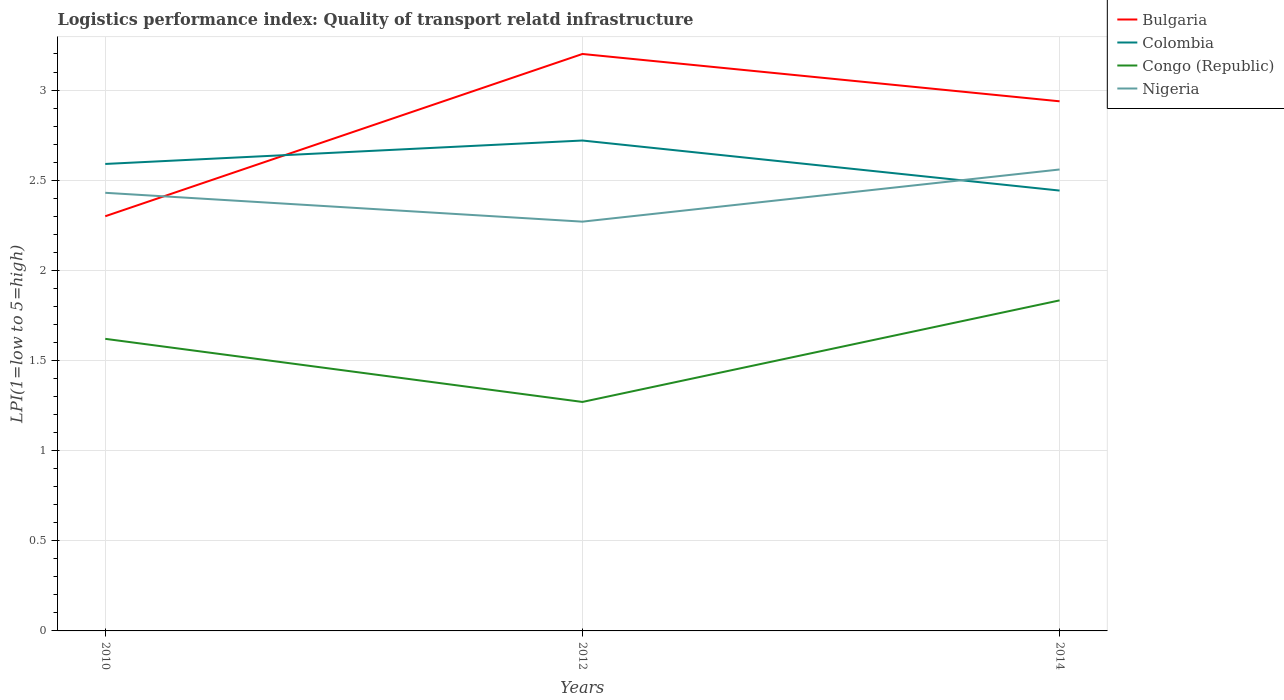How many different coloured lines are there?
Make the answer very short. 4. Is the number of lines equal to the number of legend labels?
Keep it short and to the point. Yes. Across all years, what is the maximum logistics performance index in Nigeria?
Your response must be concise. 2.27. In which year was the logistics performance index in Congo (Republic) maximum?
Your answer should be compact. 2012. What is the total logistics performance index in Bulgaria in the graph?
Offer a terse response. -0.9. What is the difference between the highest and the second highest logistics performance index in Nigeria?
Keep it short and to the point. 0.29. Is the logistics performance index in Bulgaria strictly greater than the logistics performance index in Nigeria over the years?
Make the answer very short. No. How many years are there in the graph?
Ensure brevity in your answer.  3. How many legend labels are there?
Your response must be concise. 4. How are the legend labels stacked?
Provide a short and direct response. Vertical. What is the title of the graph?
Offer a terse response. Logistics performance index: Quality of transport relatd infrastructure. What is the label or title of the Y-axis?
Make the answer very short. LPI(1=low to 5=high). What is the LPI(1=low to 5=high) in Colombia in 2010?
Provide a short and direct response. 2.59. What is the LPI(1=low to 5=high) in Congo (Republic) in 2010?
Keep it short and to the point. 1.62. What is the LPI(1=low to 5=high) of Nigeria in 2010?
Ensure brevity in your answer.  2.43. What is the LPI(1=low to 5=high) in Bulgaria in 2012?
Make the answer very short. 3.2. What is the LPI(1=low to 5=high) in Colombia in 2012?
Give a very brief answer. 2.72. What is the LPI(1=low to 5=high) in Congo (Republic) in 2012?
Your answer should be compact. 1.27. What is the LPI(1=low to 5=high) in Nigeria in 2012?
Your answer should be compact. 2.27. What is the LPI(1=low to 5=high) of Bulgaria in 2014?
Provide a succinct answer. 2.94. What is the LPI(1=low to 5=high) of Colombia in 2014?
Ensure brevity in your answer.  2.44. What is the LPI(1=low to 5=high) in Congo (Republic) in 2014?
Provide a succinct answer. 1.83. What is the LPI(1=low to 5=high) of Nigeria in 2014?
Offer a terse response. 2.56. Across all years, what is the maximum LPI(1=low to 5=high) in Bulgaria?
Your answer should be very brief. 3.2. Across all years, what is the maximum LPI(1=low to 5=high) in Colombia?
Your answer should be very brief. 2.72. Across all years, what is the maximum LPI(1=low to 5=high) in Congo (Republic)?
Make the answer very short. 1.83. Across all years, what is the maximum LPI(1=low to 5=high) in Nigeria?
Offer a very short reply. 2.56. Across all years, what is the minimum LPI(1=low to 5=high) in Bulgaria?
Ensure brevity in your answer.  2.3. Across all years, what is the minimum LPI(1=low to 5=high) in Colombia?
Offer a very short reply. 2.44. Across all years, what is the minimum LPI(1=low to 5=high) in Congo (Republic)?
Your answer should be very brief. 1.27. Across all years, what is the minimum LPI(1=low to 5=high) in Nigeria?
Provide a short and direct response. 2.27. What is the total LPI(1=low to 5=high) of Bulgaria in the graph?
Offer a very short reply. 8.44. What is the total LPI(1=low to 5=high) in Colombia in the graph?
Keep it short and to the point. 7.75. What is the total LPI(1=low to 5=high) of Congo (Republic) in the graph?
Your answer should be very brief. 4.72. What is the total LPI(1=low to 5=high) in Nigeria in the graph?
Give a very brief answer. 7.26. What is the difference between the LPI(1=low to 5=high) in Colombia in 2010 and that in 2012?
Provide a succinct answer. -0.13. What is the difference between the LPI(1=low to 5=high) in Congo (Republic) in 2010 and that in 2012?
Offer a very short reply. 0.35. What is the difference between the LPI(1=low to 5=high) in Nigeria in 2010 and that in 2012?
Give a very brief answer. 0.16. What is the difference between the LPI(1=low to 5=high) in Bulgaria in 2010 and that in 2014?
Your answer should be very brief. -0.64. What is the difference between the LPI(1=low to 5=high) of Colombia in 2010 and that in 2014?
Offer a very short reply. 0.15. What is the difference between the LPI(1=low to 5=high) in Congo (Republic) in 2010 and that in 2014?
Your answer should be compact. -0.21. What is the difference between the LPI(1=low to 5=high) of Nigeria in 2010 and that in 2014?
Keep it short and to the point. -0.13. What is the difference between the LPI(1=low to 5=high) of Bulgaria in 2012 and that in 2014?
Ensure brevity in your answer.  0.26. What is the difference between the LPI(1=low to 5=high) in Colombia in 2012 and that in 2014?
Offer a terse response. 0.28. What is the difference between the LPI(1=low to 5=high) in Congo (Republic) in 2012 and that in 2014?
Make the answer very short. -0.56. What is the difference between the LPI(1=low to 5=high) of Nigeria in 2012 and that in 2014?
Your answer should be very brief. -0.29. What is the difference between the LPI(1=low to 5=high) in Bulgaria in 2010 and the LPI(1=low to 5=high) in Colombia in 2012?
Your answer should be very brief. -0.42. What is the difference between the LPI(1=low to 5=high) of Bulgaria in 2010 and the LPI(1=low to 5=high) of Congo (Republic) in 2012?
Ensure brevity in your answer.  1.03. What is the difference between the LPI(1=low to 5=high) of Bulgaria in 2010 and the LPI(1=low to 5=high) of Nigeria in 2012?
Offer a terse response. 0.03. What is the difference between the LPI(1=low to 5=high) of Colombia in 2010 and the LPI(1=low to 5=high) of Congo (Republic) in 2012?
Offer a very short reply. 1.32. What is the difference between the LPI(1=low to 5=high) of Colombia in 2010 and the LPI(1=low to 5=high) of Nigeria in 2012?
Keep it short and to the point. 0.32. What is the difference between the LPI(1=low to 5=high) of Congo (Republic) in 2010 and the LPI(1=low to 5=high) of Nigeria in 2012?
Your answer should be compact. -0.65. What is the difference between the LPI(1=low to 5=high) in Bulgaria in 2010 and the LPI(1=low to 5=high) in Colombia in 2014?
Ensure brevity in your answer.  -0.14. What is the difference between the LPI(1=low to 5=high) of Bulgaria in 2010 and the LPI(1=low to 5=high) of Congo (Republic) in 2014?
Provide a short and direct response. 0.47. What is the difference between the LPI(1=low to 5=high) of Bulgaria in 2010 and the LPI(1=low to 5=high) of Nigeria in 2014?
Give a very brief answer. -0.26. What is the difference between the LPI(1=low to 5=high) of Colombia in 2010 and the LPI(1=low to 5=high) of Congo (Republic) in 2014?
Your answer should be very brief. 0.76. What is the difference between the LPI(1=low to 5=high) in Colombia in 2010 and the LPI(1=low to 5=high) in Nigeria in 2014?
Provide a short and direct response. 0.03. What is the difference between the LPI(1=low to 5=high) in Congo (Republic) in 2010 and the LPI(1=low to 5=high) in Nigeria in 2014?
Offer a terse response. -0.94. What is the difference between the LPI(1=low to 5=high) in Bulgaria in 2012 and the LPI(1=low to 5=high) in Colombia in 2014?
Give a very brief answer. 0.76. What is the difference between the LPI(1=low to 5=high) in Bulgaria in 2012 and the LPI(1=low to 5=high) in Congo (Republic) in 2014?
Keep it short and to the point. 1.37. What is the difference between the LPI(1=low to 5=high) in Bulgaria in 2012 and the LPI(1=low to 5=high) in Nigeria in 2014?
Provide a short and direct response. 0.64. What is the difference between the LPI(1=low to 5=high) in Colombia in 2012 and the LPI(1=low to 5=high) in Congo (Republic) in 2014?
Offer a very short reply. 0.89. What is the difference between the LPI(1=low to 5=high) of Colombia in 2012 and the LPI(1=low to 5=high) of Nigeria in 2014?
Offer a terse response. 0.16. What is the difference between the LPI(1=low to 5=high) of Congo (Republic) in 2012 and the LPI(1=low to 5=high) of Nigeria in 2014?
Keep it short and to the point. -1.29. What is the average LPI(1=low to 5=high) of Bulgaria per year?
Offer a terse response. 2.81. What is the average LPI(1=low to 5=high) in Colombia per year?
Offer a very short reply. 2.58. What is the average LPI(1=low to 5=high) in Congo (Republic) per year?
Your answer should be compact. 1.57. What is the average LPI(1=low to 5=high) in Nigeria per year?
Provide a succinct answer. 2.42. In the year 2010, what is the difference between the LPI(1=low to 5=high) of Bulgaria and LPI(1=low to 5=high) of Colombia?
Offer a terse response. -0.29. In the year 2010, what is the difference between the LPI(1=low to 5=high) of Bulgaria and LPI(1=low to 5=high) of Congo (Republic)?
Provide a short and direct response. 0.68. In the year 2010, what is the difference between the LPI(1=low to 5=high) in Bulgaria and LPI(1=low to 5=high) in Nigeria?
Keep it short and to the point. -0.13. In the year 2010, what is the difference between the LPI(1=low to 5=high) of Colombia and LPI(1=low to 5=high) of Congo (Republic)?
Provide a succinct answer. 0.97. In the year 2010, what is the difference between the LPI(1=low to 5=high) in Colombia and LPI(1=low to 5=high) in Nigeria?
Offer a very short reply. 0.16. In the year 2010, what is the difference between the LPI(1=low to 5=high) in Congo (Republic) and LPI(1=low to 5=high) in Nigeria?
Ensure brevity in your answer.  -0.81. In the year 2012, what is the difference between the LPI(1=low to 5=high) of Bulgaria and LPI(1=low to 5=high) of Colombia?
Give a very brief answer. 0.48. In the year 2012, what is the difference between the LPI(1=low to 5=high) in Bulgaria and LPI(1=low to 5=high) in Congo (Republic)?
Make the answer very short. 1.93. In the year 2012, what is the difference between the LPI(1=low to 5=high) in Bulgaria and LPI(1=low to 5=high) in Nigeria?
Keep it short and to the point. 0.93. In the year 2012, what is the difference between the LPI(1=low to 5=high) of Colombia and LPI(1=low to 5=high) of Congo (Republic)?
Ensure brevity in your answer.  1.45. In the year 2012, what is the difference between the LPI(1=low to 5=high) in Colombia and LPI(1=low to 5=high) in Nigeria?
Your answer should be very brief. 0.45. In the year 2014, what is the difference between the LPI(1=low to 5=high) in Bulgaria and LPI(1=low to 5=high) in Colombia?
Provide a short and direct response. 0.5. In the year 2014, what is the difference between the LPI(1=low to 5=high) of Bulgaria and LPI(1=low to 5=high) of Congo (Republic)?
Ensure brevity in your answer.  1.1. In the year 2014, what is the difference between the LPI(1=low to 5=high) of Bulgaria and LPI(1=low to 5=high) of Nigeria?
Make the answer very short. 0.38. In the year 2014, what is the difference between the LPI(1=low to 5=high) in Colombia and LPI(1=low to 5=high) in Congo (Republic)?
Provide a short and direct response. 0.61. In the year 2014, what is the difference between the LPI(1=low to 5=high) of Colombia and LPI(1=low to 5=high) of Nigeria?
Your answer should be compact. -0.12. In the year 2014, what is the difference between the LPI(1=low to 5=high) in Congo (Republic) and LPI(1=low to 5=high) in Nigeria?
Your answer should be compact. -0.73. What is the ratio of the LPI(1=low to 5=high) of Bulgaria in 2010 to that in 2012?
Provide a short and direct response. 0.72. What is the ratio of the LPI(1=low to 5=high) of Colombia in 2010 to that in 2012?
Ensure brevity in your answer.  0.95. What is the ratio of the LPI(1=low to 5=high) in Congo (Republic) in 2010 to that in 2012?
Provide a succinct answer. 1.28. What is the ratio of the LPI(1=low to 5=high) in Nigeria in 2010 to that in 2012?
Provide a succinct answer. 1.07. What is the ratio of the LPI(1=low to 5=high) in Bulgaria in 2010 to that in 2014?
Provide a succinct answer. 0.78. What is the ratio of the LPI(1=low to 5=high) in Colombia in 2010 to that in 2014?
Your answer should be very brief. 1.06. What is the ratio of the LPI(1=low to 5=high) of Congo (Republic) in 2010 to that in 2014?
Provide a succinct answer. 0.88. What is the ratio of the LPI(1=low to 5=high) of Nigeria in 2010 to that in 2014?
Your answer should be compact. 0.95. What is the ratio of the LPI(1=low to 5=high) of Bulgaria in 2012 to that in 2014?
Your answer should be compact. 1.09. What is the ratio of the LPI(1=low to 5=high) of Colombia in 2012 to that in 2014?
Keep it short and to the point. 1.11. What is the ratio of the LPI(1=low to 5=high) of Congo (Republic) in 2012 to that in 2014?
Your response must be concise. 0.69. What is the ratio of the LPI(1=low to 5=high) of Nigeria in 2012 to that in 2014?
Make the answer very short. 0.89. What is the difference between the highest and the second highest LPI(1=low to 5=high) of Bulgaria?
Provide a short and direct response. 0.26. What is the difference between the highest and the second highest LPI(1=low to 5=high) in Colombia?
Your answer should be very brief. 0.13. What is the difference between the highest and the second highest LPI(1=low to 5=high) in Congo (Republic)?
Keep it short and to the point. 0.21. What is the difference between the highest and the second highest LPI(1=low to 5=high) of Nigeria?
Your answer should be compact. 0.13. What is the difference between the highest and the lowest LPI(1=low to 5=high) of Colombia?
Keep it short and to the point. 0.28. What is the difference between the highest and the lowest LPI(1=low to 5=high) of Congo (Republic)?
Keep it short and to the point. 0.56. What is the difference between the highest and the lowest LPI(1=low to 5=high) of Nigeria?
Ensure brevity in your answer.  0.29. 